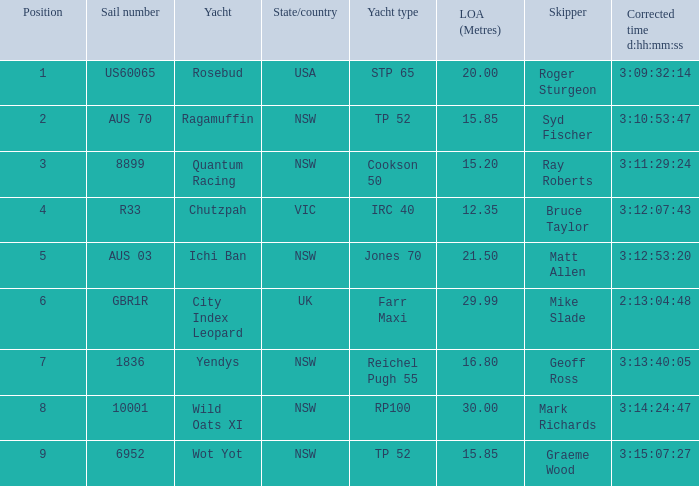What are all of the states or countries with a corrected time 3:13:40:05? NSW. 